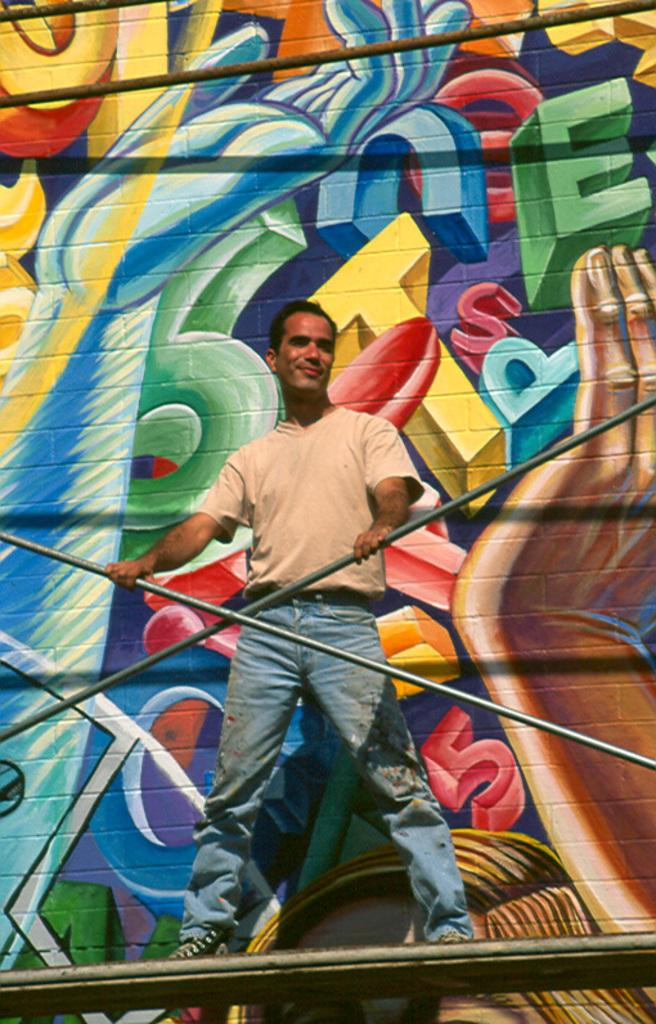What is the man doing in the image? The man is standing on the platform. What is the man's facial expression in the image? The man is smiling. What objects can be seen in the image besides the man? There are rods visible in the image. What is on the wall behind the man? There is a painting on the wall behind the man. What type of road can be seen in the image? There is no road present in the image. What kind of voyage is the man embarking on in the image? The image does not depict a voyage, and there is no indication of the man's plans or intentions. 